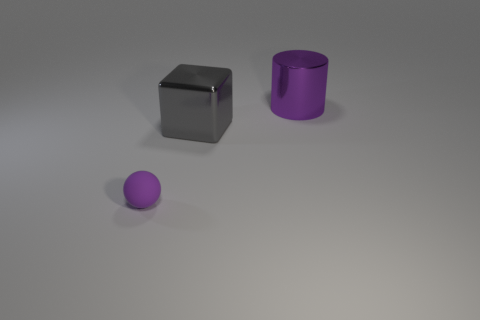Add 2 brown metal cubes. How many objects exist? 5 Subtract all balls. How many objects are left? 2 Subtract all big green matte spheres. Subtract all large gray shiny things. How many objects are left? 2 Add 3 purple cylinders. How many purple cylinders are left? 4 Add 2 gray objects. How many gray objects exist? 3 Subtract 0 cyan balls. How many objects are left? 3 